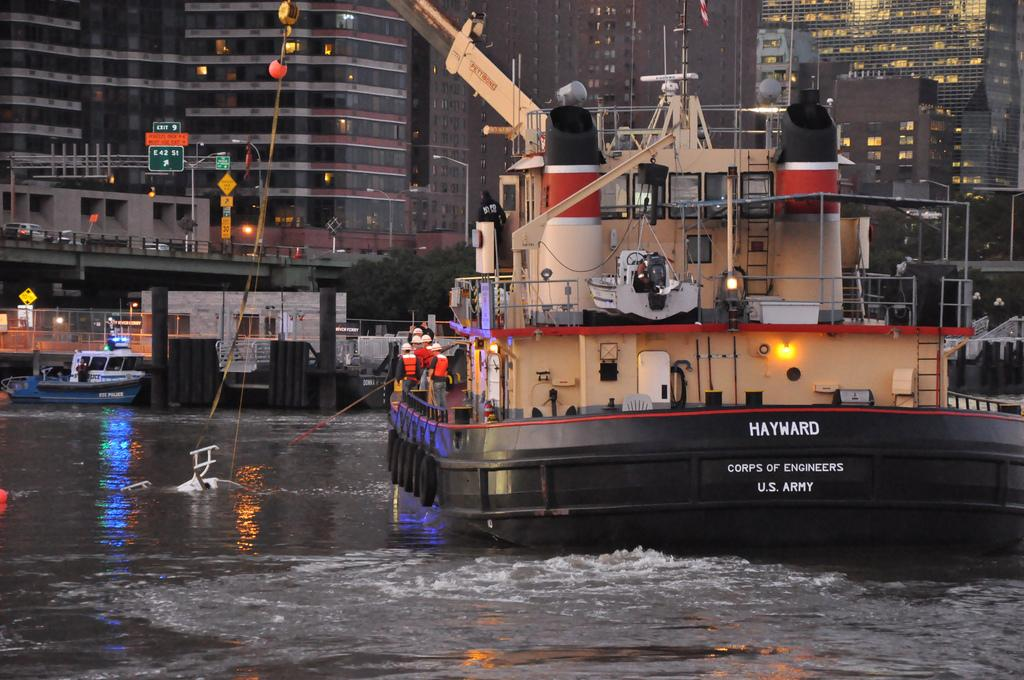What are the people in the image doing? The people in the image are standing in a ship. Where is the ship located? The ship is on a river. Are there any other ships visible in the image? Yes, there is another ship in the image. What can be seen in the background of the image? There are buildings in the background of the image. What type of corn is being grown on the ship in the image? There is no corn present in the image; it features people standing in a ship on a river. Can you tell me how many dogs are visible on the ship in the image? There are no dogs present in the image; it features people standing in a ship on a river. 